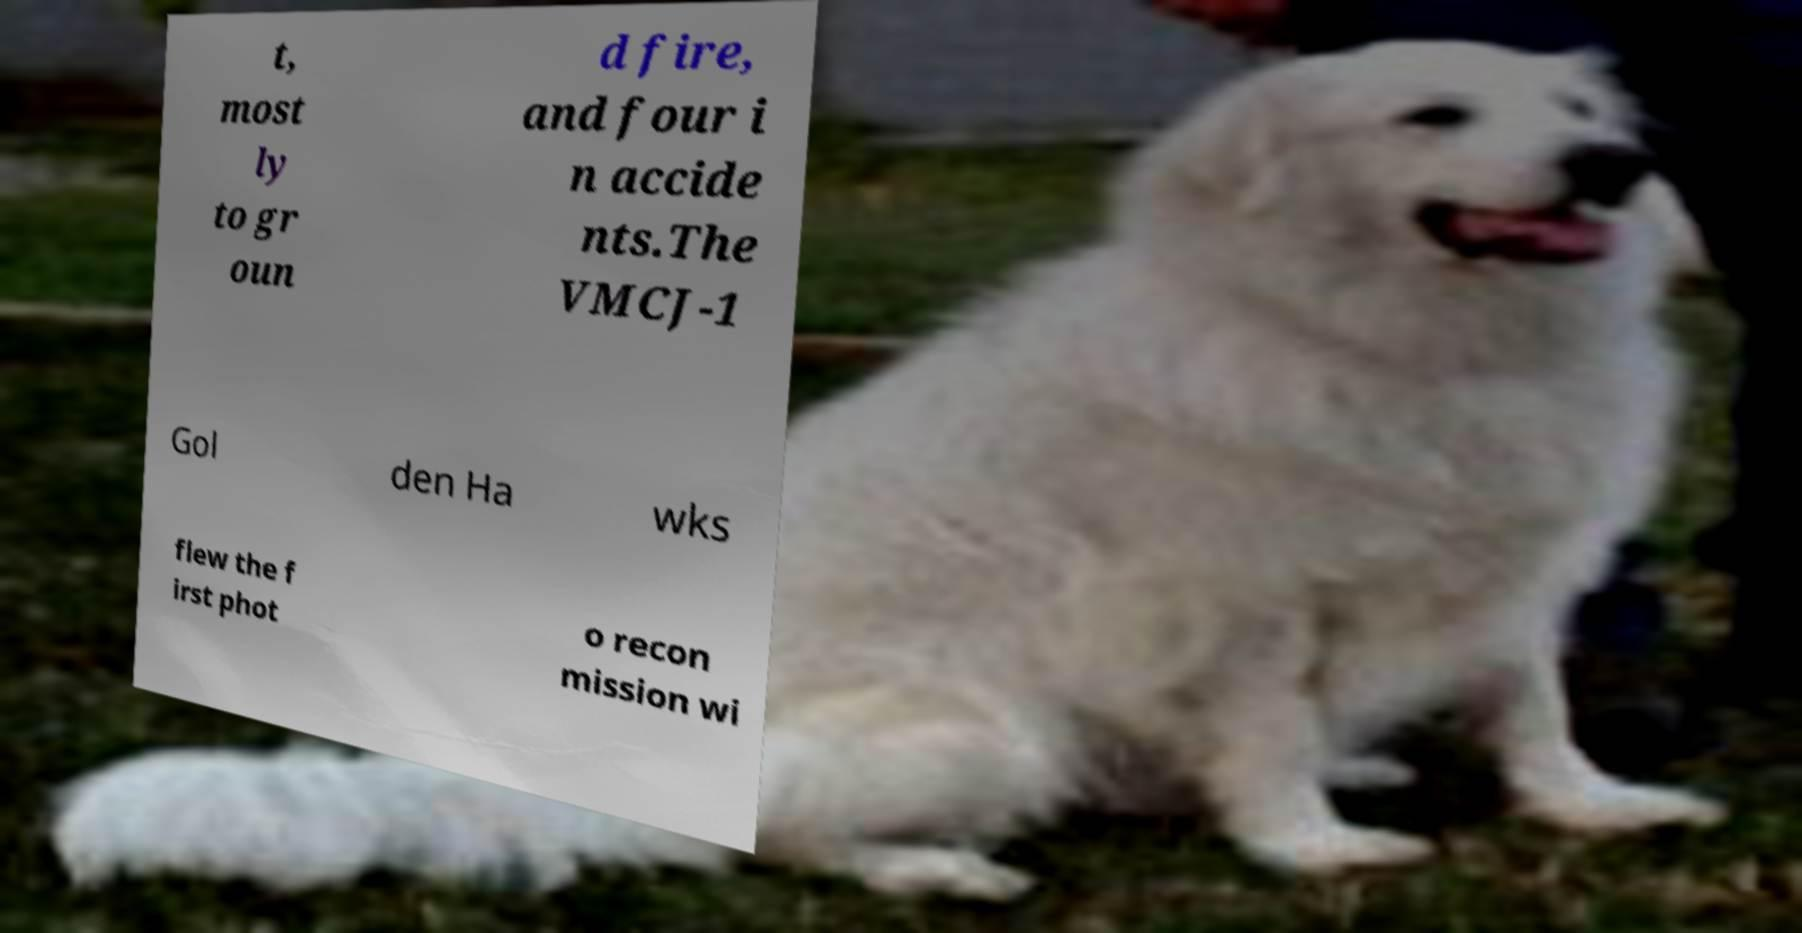Please read and relay the text visible in this image. What does it say? t, most ly to gr oun d fire, and four i n accide nts.The VMCJ-1 Gol den Ha wks flew the f irst phot o recon mission wi 